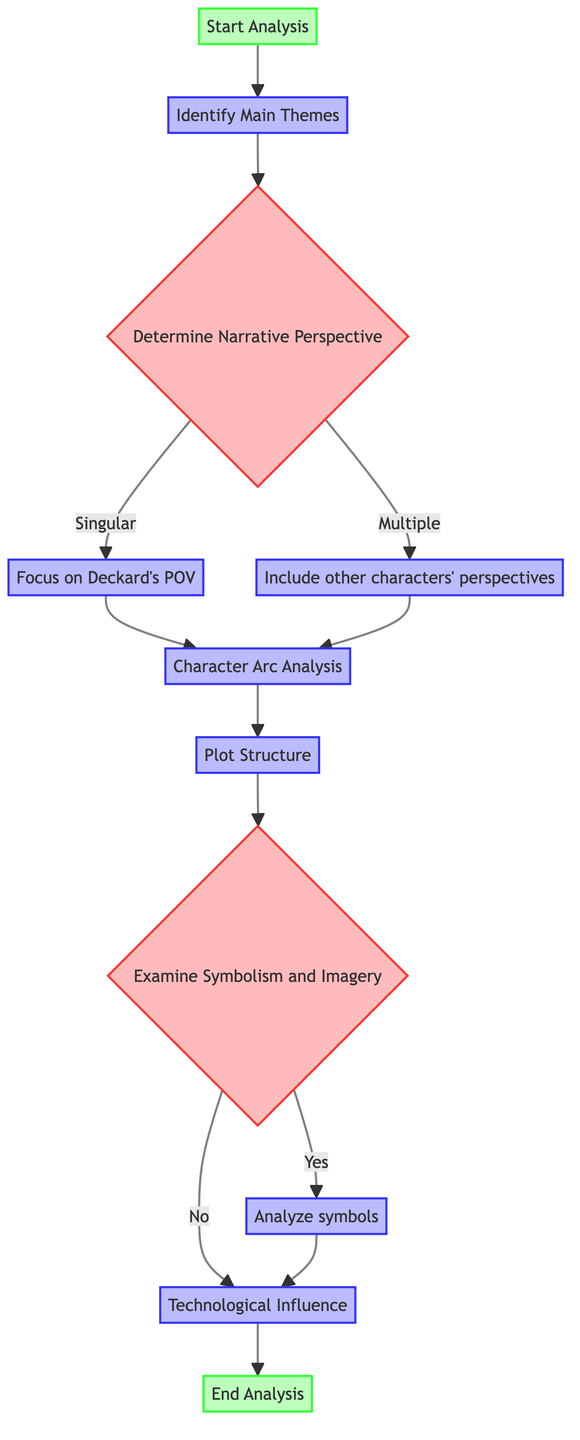What is the first step in the analysis? The first step, represented by the "Start Analysis" node, begins the narrative structure analysis of 'Blade Runner.'
Answer: Start Analysis How many decision nodes are present in the diagram? By examining the diagram, there are two decision nodes: "Determine Narrative Perspective" and "Examine Symbolism and Imagery."
Answer: 2 What are the two options available under "Determine Narrative Perspective"? The options listed under this decision are "Singular" and "Multiple," indicating the perspectives the narrative may take.
Answer: Singular, Multiple What follows after "Focus on Deckard's POV"? After this process, the next step is "Character Arc Analysis," which evaluates the development of main characters.
Answer: Character Arc Analysis If the answer to "Examine Symbolism and Imagery" is 'yes', which step occurs next? If 'yes' is selected, the analysis continues to "Analyze symbols like the unicorn, eyes, and cityscape" before moving on.
Answer: Analyze symbols What is the last step in the analysis process? The final step indicated by the flowchart is "End Analysis," which signifies the completion of the narrative structure analysis.
Answer: End Analysis How does the flowchart suggest dealing with the narrative perspective? The flowchart provides two paths based on the decision from "Determine Narrative Perspective," either focusing on Deckard's POV or including multiple characters' perspectives.
Answer: Focus on Deckard's POV, Include other characters' perspectives What is the process immediately following "Plot Structure"? Following "Plot Structure," the next decision presented is "Examine Symbolism and Imagery," where further analysis is determined.
Answer: Examine Symbolism and Imagery What is the significance of the node labeled 'Technological Influence'? The "Technological Influence" process assesses the impact of technology on the narrative and world-building within 'Blade Runner.'
Answer: Assess how technology influences the narrative and the world-building 